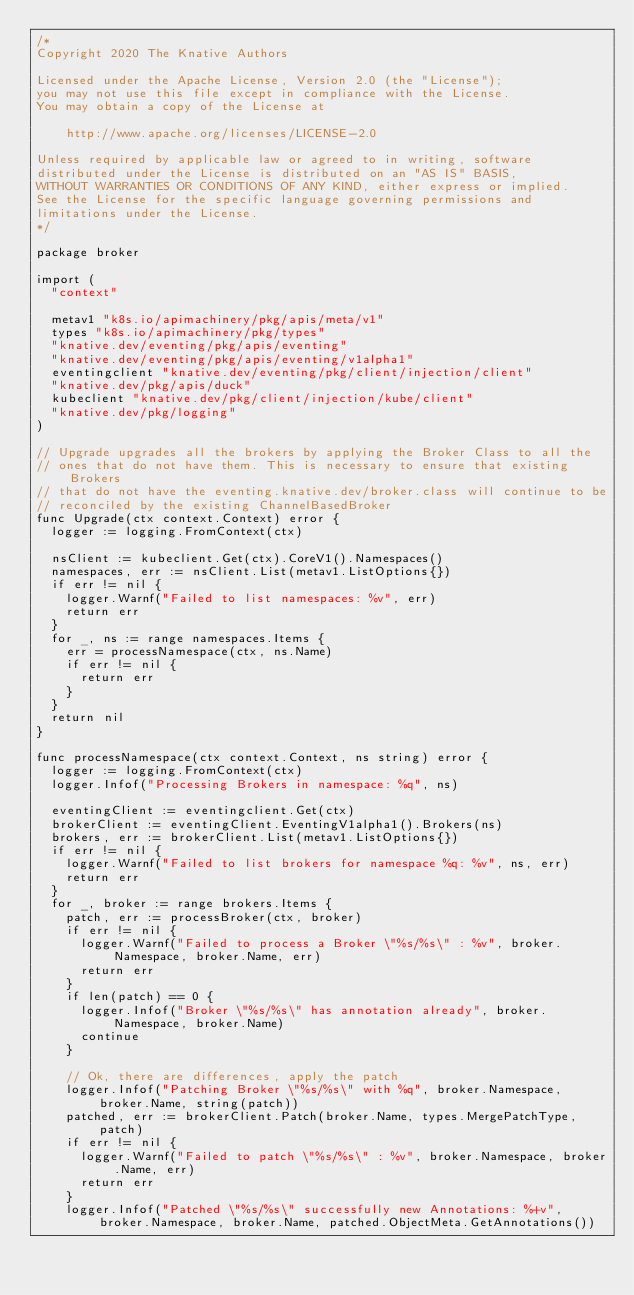Convert code to text. <code><loc_0><loc_0><loc_500><loc_500><_Go_>/*
Copyright 2020 The Knative Authors

Licensed under the Apache License, Version 2.0 (the "License");
you may not use this file except in compliance with the License.
You may obtain a copy of the License at

    http://www.apache.org/licenses/LICENSE-2.0

Unless required by applicable law or agreed to in writing, software
distributed under the License is distributed on an "AS IS" BASIS,
WITHOUT WARRANTIES OR CONDITIONS OF ANY KIND, either express or implied.
See the License for the specific language governing permissions and
limitations under the License.
*/

package broker

import (
	"context"

	metav1 "k8s.io/apimachinery/pkg/apis/meta/v1"
	types "k8s.io/apimachinery/pkg/types"
	"knative.dev/eventing/pkg/apis/eventing"
	"knative.dev/eventing/pkg/apis/eventing/v1alpha1"
	eventingclient "knative.dev/eventing/pkg/client/injection/client"
	"knative.dev/pkg/apis/duck"
	kubeclient "knative.dev/pkg/client/injection/kube/client"
	"knative.dev/pkg/logging"
)

// Upgrade upgrades all the brokers by applying the Broker Class to all the
// ones that do not have them. This is necessary to ensure that existing Brokers
// that do not have the eventing.knative.dev/broker.class will continue to be
// reconciled by the existing ChannelBasedBroker
func Upgrade(ctx context.Context) error {
	logger := logging.FromContext(ctx)

	nsClient := kubeclient.Get(ctx).CoreV1().Namespaces()
	namespaces, err := nsClient.List(metav1.ListOptions{})
	if err != nil {
		logger.Warnf("Failed to list namespaces: %v", err)
		return err
	}
	for _, ns := range namespaces.Items {
		err = processNamespace(ctx, ns.Name)
		if err != nil {
			return err
		}
	}
	return nil
}

func processNamespace(ctx context.Context, ns string) error {
	logger := logging.FromContext(ctx)
	logger.Infof("Processing Brokers in namespace: %q", ns)

	eventingClient := eventingclient.Get(ctx)
	brokerClient := eventingClient.EventingV1alpha1().Brokers(ns)
	brokers, err := brokerClient.List(metav1.ListOptions{})
	if err != nil {
		logger.Warnf("Failed to list brokers for namespace %q: %v", ns, err)
		return err
	}
	for _, broker := range brokers.Items {
		patch, err := processBroker(ctx, broker)
		if err != nil {
			logger.Warnf("Failed to process a Broker \"%s/%s\" : %v", broker.Namespace, broker.Name, err)
			return err
		}
		if len(patch) == 0 {
			logger.Infof("Broker \"%s/%s\" has annotation already", broker.Namespace, broker.Name)
			continue
		}

		// Ok, there are differences, apply the patch
		logger.Infof("Patching Broker \"%s/%s\" with %q", broker.Namespace, broker.Name, string(patch))
		patched, err := brokerClient.Patch(broker.Name, types.MergePatchType, patch)
		if err != nil {
			logger.Warnf("Failed to patch \"%s/%s\" : %v", broker.Namespace, broker.Name, err)
			return err
		}
		logger.Infof("Patched \"%s/%s\" successfully new Annotations: %+v", broker.Namespace, broker.Name, patched.ObjectMeta.GetAnnotations())</code> 